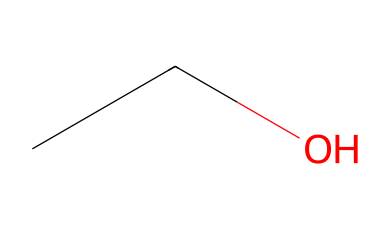What is the molecular formula of this compound? The SMILES representation depicts ethanol, which consists of two carbon atoms (C), six hydrogen atoms (H), and one oxygen atom (O). Thus, the molecular formula is C2H6O.
Answer: C2H6O How many hydrogen atoms are present in this molecule? The SMILES shows that there are a total of six hydrogen atoms attached to the carbon and oxygen atoms in ethanol.
Answer: six What type of bond exists between the carbon and oxygen in ethanol? In the structure of ethanol, the bond between carbon and oxygen is a single bond (C-O), as indicated by the absence of any symbols indicating double or triple bonds in the SMILES notation.
Answer: single bond Is ethanol a saturated or unsaturated compound? Since ethanol contains only single bonds between its carbon and hydrogen atoms (as indicated by the SMILES), it is classified as a saturated compound.
Answer: saturated What functional group is present in ethanol? The presence of the —OH group (hydroxyl group) in the structure indicates that ethanol has a functional group characteristic of alcohols.
Answer: hydroxyl How many total atoms are there in the ethanol molecule? Ethanol has a total of nine atoms: two carbon, six hydrogen, and one oxygen. This can be calculated by simply adding these now known quantities together.
Answer: nine 